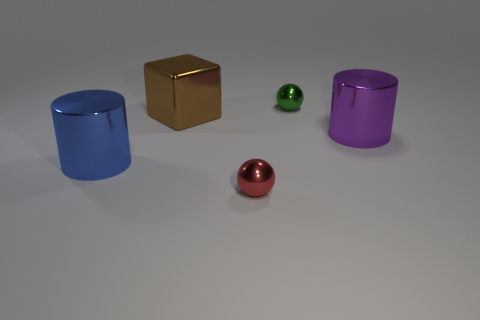Add 3 big purple metallic objects. How many objects exist? 8 Subtract all purple cylinders. How many cylinders are left? 1 Subtract 1 balls. How many balls are left? 1 Subtract all green cubes. Subtract all yellow cylinders. How many cubes are left? 1 Subtract all yellow cubes. How many green cylinders are left? 0 Subtract all large brown cubes. Subtract all big brown things. How many objects are left? 3 Add 3 big cylinders. How many big cylinders are left? 5 Add 2 metallic blocks. How many metallic blocks exist? 3 Subtract 0 green cubes. How many objects are left? 5 Subtract all balls. How many objects are left? 3 